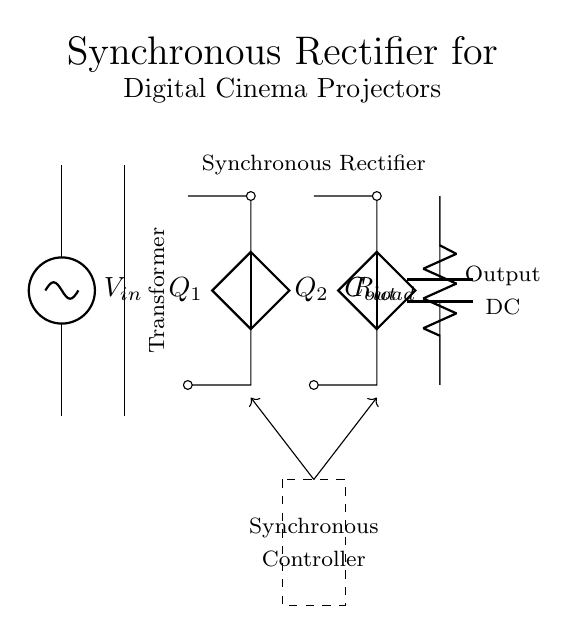What is the input voltage of the circuit? The input voltage is labeled as V_in, which is connected to the input AC source at the top of the circuit diagram.
Answer: V_in What type of transformer is used in this circuit? The circuit diagram indicates a transformer core, labeled simply as a transformer without specifying the type, which typically serves to step up or step down voltage levels.
Answer: Transformer How many diodes are represented in the circuit? There are two components denoted as Q_1 and Q_2 in the circuit diagram, which function as diodes in the rectifier setup.
Answer: Two What component smooths the output voltage? The circuit includes a capacitor labeled C_out, which is positioned at the output and is primarily responsible for smoothing the DC voltage from the rectifier.
Answer: C_out What role does the synchronous controller play in the circuit? The dashed rectangle surrounds the synchronous controller, which manages the operation of the diodes (Q_1 and Q_2) to enhance efficiency by reducing voltage drop during rectification.
Answer: Efficiency What is the load connected to the output of the circuit? The output of the circuit includes a resistor labeled R_load, which represents the load that the output voltage will power.
Answer: R_load How does the synchronous rectifier improve energy efficiency? The synchronous rectifier uses active components (diodes like Q_1 and Q_2) controlled by the synchronous controller to minimize power losses, which enhances overall energy efficiency compared to passive rectifiers.
Answer: Power losses 